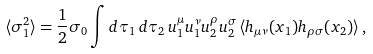<formula> <loc_0><loc_0><loc_500><loc_500>\langle \sigma _ { 1 } ^ { 2 } \rangle = \frac { 1 } { 2 } \sigma _ { 0 } \int d \tau _ { 1 } \, d \tau _ { 2 } \, u _ { 1 } ^ { \mu } u _ { 1 } ^ { \nu } u _ { 2 } ^ { \rho } u _ { 2 } ^ { \sigma } \, \langle h _ { \mu \nu } ( x _ { 1 } ) h _ { \rho \sigma } ( x _ { 2 } ) \rangle \, ,</formula> 